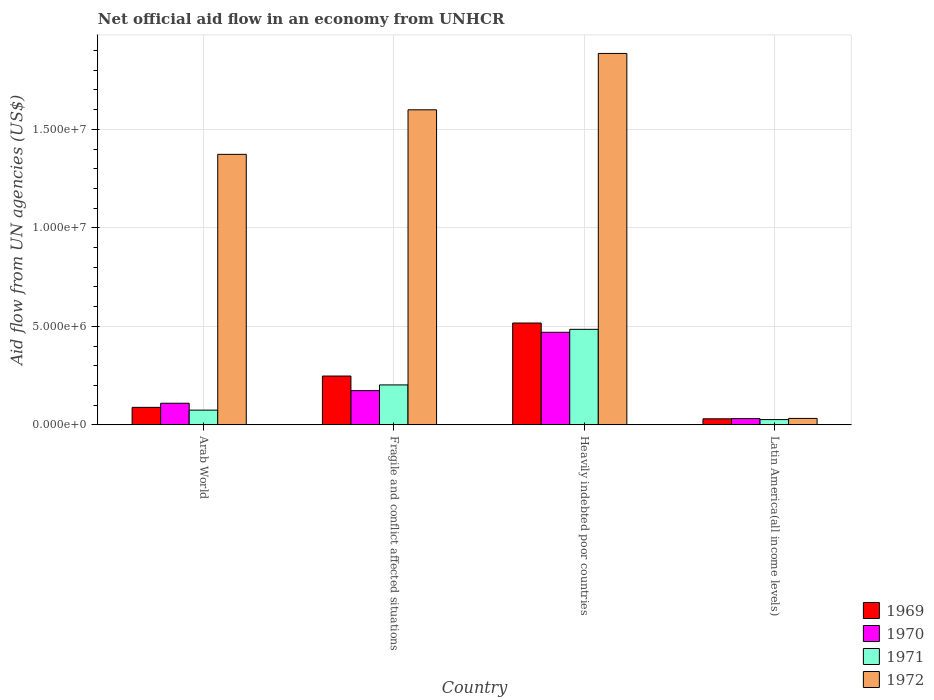How many different coloured bars are there?
Give a very brief answer. 4. How many groups of bars are there?
Give a very brief answer. 4. Are the number of bars per tick equal to the number of legend labels?
Keep it short and to the point. Yes. How many bars are there on the 4th tick from the left?
Provide a short and direct response. 4. How many bars are there on the 1st tick from the right?
Your answer should be compact. 4. What is the label of the 1st group of bars from the left?
Ensure brevity in your answer.  Arab World. What is the net official aid flow in 1969 in Latin America(all income levels)?
Keep it short and to the point. 3.10e+05. Across all countries, what is the maximum net official aid flow in 1969?
Your response must be concise. 5.17e+06. In which country was the net official aid flow in 1971 maximum?
Your answer should be very brief. Heavily indebted poor countries. In which country was the net official aid flow in 1971 minimum?
Offer a terse response. Latin America(all income levels). What is the total net official aid flow in 1969 in the graph?
Keep it short and to the point. 8.85e+06. What is the difference between the net official aid flow in 1971 in Arab World and that in Fragile and conflict affected situations?
Your answer should be very brief. -1.28e+06. What is the difference between the net official aid flow in 1969 in Latin America(all income levels) and the net official aid flow in 1970 in Heavily indebted poor countries?
Your response must be concise. -4.39e+06. What is the average net official aid flow in 1972 per country?
Keep it short and to the point. 1.22e+07. What is the difference between the net official aid flow of/in 1971 and net official aid flow of/in 1970 in Arab World?
Ensure brevity in your answer.  -3.50e+05. In how many countries, is the net official aid flow in 1971 greater than 5000000 US$?
Offer a terse response. 0. What is the ratio of the net official aid flow in 1970 in Fragile and conflict affected situations to that in Heavily indebted poor countries?
Provide a short and direct response. 0.37. Is the net official aid flow in 1970 in Heavily indebted poor countries less than that in Latin America(all income levels)?
Make the answer very short. No. What is the difference between the highest and the second highest net official aid flow in 1972?
Give a very brief answer. 2.86e+06. What is the difference between the highest and the lowest net official aid flow in 1971?
Ensure brevity in your answer.  4.58e+06. Is the sum of the net official aid flow in 1970 in Fragile and conflict affected situations and Latin America(all income levels) greater than the maximum net official aid flow in 1971 across all countries?
Offer a terse response. No. Is it the case that in every country, the sum of the net official aid flow in 1971 and net official aid flow in 1969 is greater than the sum of net official aid flow in 1970 and net official aid flow in 1972?
Keep it short and to the point. No. What does the 4th bar from the right in Latin America(all income levels) represents?
Ensure brevity in your answer.  1969. Are all the bars in the graph horizontal?
Your answer should be compact. No. How many legend labels are there?
Your answer should be compact. 4. How are the legend labels stacked?
Ensure brevity in your answer.  Vertical. What is the title of the graph?
Give a very brief answer. Net official aid flow in an economy from UNHCR. Does "1994" appear as one of the legend labels in the graph?
Provide a succinct answer. No. What is the label or title of the Y-axis?
Ensure brevity in your answer.  Aid flow from UN agencies (US$). What is the Aid flow from UN agencies (US$) of 1969 in Arab World?
Provide a short and direct response. 8.90e+05. What is the Aid flow from UN agencies (US$) of 1970 in Arab World?
Ensure brevity in your answer.  1.10e+06. What is the Aid flow from UN agencies (US$) in 1971 in Arab World?
Give a very brief answer. 7.50e+05. What is the Aid flow from UN agencies (US$) of 1972 in Arab World?
Provide a short and direct response. 1.37e+07. What is the Aid flow from UN agencies (US$) of 1969 in Fragile and conflict affected situations?
Provide a succinct answer. 2.48e+06. What is the Aid flow from UN agencies (US$) of 1970 in Fragile and conflict affected situations?
Provide a short and direct response. 1.74e+06. What is the Aid flow from UN agencies (US$) of 1971 in Fragile and conflict affected situations?
Offer a very short reply. 2.03e+06. What is the Aid flow from UN agencies (US$) of 1972 in Fragile and conflict affected situations?
Provide a succinct answer. 1.60e+07. What is the Aid flow from UN agencies (US$) in 1969 in Heavily indebted poor countries?
Your response must be concise. 5.17e+06. What is the Aid flow from UN agencies (US$) of 1970 in Heavily indebted poor countries?
Provide a succinct answer. 4.70e+06. What is the Aid flow from UN agencies (US$) in 1971 in Heavily indebted poor countries?
Offer a terse response. 4.85e+06. What is the Aid flow from UN agencies (US$) of 1972 in Heavily indebted poor countries?
Your response must be concise. 1.88e+07. What is the Aid flow from UN agencies (US$) of 1971 in Latin America(all income levels)?
Provide a succinct answer. 2.70e+05. Across all countries, what is the maximum Aid flow from UN agencies (US$) in 1969?
Give a very brief answer. 5.17e+06. Across all countries, what is the maximum Aid flow from UN agencies (US$) of 1970?
Keep it short and to the point. 4.70e+06. Across all countries, what is the maximum Aid flow from UN agencies (US$) in 1971?
Ensure brevity in your answer.  4.85e+06. Across all countries, what is the maximum Aid flow from UN agencies (US$) in 1972?
Your answer should be compact. 1.88e+07. Across all countries, what is the minimum Aid flow from UN agencies (US$) of 1969?
Your answer should be very brief. 3.10e+05. Across all countries, what is the minimum Aid flow from UN agencies (US$) in 1972?
Provide a succinct answer. 3.30e+05. What is the total Aid flow from UN agencies (US$) in 1969 in the graph?
Make the answer very short. 8.85e+06. What is the total Aid flow from UN agencies (US$) of 1970 in the graph?
Make the answer very short. 7.86e+06. What is the total Aid flow from UN agencies (US$) in 1971 in the graph?
Your answer should be very brief. 7.90e+06. What is the total Aid flow from UN agencies (US$) of 1972 in the graph?
Offer a terse response. 4.89e+07. What is the difference between the Aid flow from UN agencies (US$) in 1969 in Arab World and that in Fragile and conflict affected situations?
Offer a terse response. -1.59e+06. What is the difference between the Aid flow from UN agencies (US$) in 1970 in Arab World and that in Fragile and conflict affected situations?
Your answer should be compact. -6.40e+05. What is the difference between the Aid flow from UN agencies (US$) of 1971 in Arab World and that in Fragile and conflict affected situations?
Make the answer very short. -1.28e+06. What is the difference between the Aid flow from UN agencies (US$) in 1972 in Arab World and that in Fragile and conflict affected situations?
Keep it short and to the point. -2.26e+06. What is the difference between the Aid flow from UN agencies (US$) in 1969 in Arab World and that in Heavily indebted poor countries?
Provide a succinct answer. -4.28e+06. What is the difference between the Aid flow from UN agencies (US$) in 1970 in Arab World and that in Heavily indebted poor countries?
Your response must be concise. -3.60e+06. What is the difference between the Aid flow from UN agencies (US$) of 1971 in Arab World and that in Heavily indebted poor countries?
Your answer should be compact. -4.10e+06. What is the difference between the Aid flow from UN agencies (US$) in 1972 in Arab World and that in Heavily indebted poor countries?
Make the answer very short. -5.12e+06. What is the difference between the Aid flow from UN agencies (US$) of 1969 in Arab World and that in Latin America(all income levels)?
Provide a short and direct response. 5.80e+05. What is the difference between the Aid flow from UN agencies (US$) of 1970 in Arab World and that in Latin America(all income levels)?
Your answer should be very brief. 7.80e+05. What is the difference between the Aid flow from UN agencies (US$) in 1971 in Arab World and that in Latin America(all income levels)?
Your response must be concise. 4.80e+05. What is the difference between the Aid flow from UN agencies (US$) of 1972 in Arab World and that in Latin America(all income levels)?
Offer a very short reply. 1.34e+07. What is the difference between the Aid flow from UN agencies (US$) in 1969 in Fragile and conflict affected situations and that in Heavily indebted poor countries?
Keep it short and to the point. -2.69e+06. What is the difference between the Aid flow from UN agencies (US$) of 1970 in Fragile and conflict affected situations and that in Heavily indebted poor countries?
Your answer should be very brief. -2.96e+06. What is the difference between the Aid flow from UN agencies (US$) of 1971 in Fragile and conflict affected situations and that in Heavily indebted poor countries?
Your response must be concise. -2.82e+06. What is the difference between the Aid flow from UN agencies (US$) of 1972 in Fragile and conflict affected situations and that in Heavily indebted poor countries?
Give a very brief answer. -2.86e+06. What is the difference between the Aid flow from UN agencies (US$) in 1969 in Fragile and conflict affected situations and that in Latin America(all income levels)?
Offer a very short reply. 2.17e+06. What is the difference between the Aid flow from UN agencies (US$) of 1970 in Fragile and conflict affected situations and that in Latin America(all income levels)?
Your answer should be very brief. 1.42e+06. What is the difference between the Aid flow from UN agencies (US$) of 1971 in Fragile and conflict affected situations and that in Latin America(all income levels)?
Offer a very short reply. 1.76e+06. What is the difference between the Aid flow from UN agencies (US$) in 1972 in Fragile and conflict affected situations and that in Latin America(all income levels)?
Your answer should be compact. 1.57e+07. What is the difference between the Aid flow from UN agencies (US$) of 1969 in Heavily indebted poor countries and that in Latin America(all income levels)?
Your answer should be compact. 4.86e+06. What is the difference between the Aid flow from UN agencies (US$) in 1970 in Heavily indebted poor countries and that in Latin America(all income levels)?
Offer a very short reply. 4.38e+06. What is the difference between the Aid flow from UN agencies (US$) of 1971 in Heavily indebted poor countries and that in Latin America(all income levels)?
Your response must be concise. 4.58e+06. What is the difference between the Aid flow from UN agencies (US$) of 1972 in Heavily indebted poor countries and that in Latin America(all income levels)?
Make the answer very short. 1.85e+07. What is the difference between the Aid flow from UN agencies (US$) of 1969 in Arab World and the Aid flow from UN agencies (US$) of 1970 in Fragile and conflict affected situations?
Provide a short and direct response. -8.50e+05. What is the difference between the Aid flow from UN agencies (US$) in 1969 in Arab World and the Aid flow from UN agencies (US$) in 1971 in Fragile and conflict affected situations?
Provide a succinct answer. -1.14e+06. What is the difference between the Aid flow from UN agencies (US$) of 1969 in Arab World and the Aid flow from UN agencies (US$) of 1972 in Fragile and conflict affected situations?
Your response must be concise. -1.51e+07. What is the difference between the Aid flow from UN agencies (US$) in 1970 in Arab World and the Aid flow from UN agencies (US$) in 1971 in Fragile and conflict affected situations?
Your answer should be compact. -9.30e+05. What is the difference between the Aid flow from UN agencies (US$) in 1970 in Arab World and the Aid flow from UN agencies (US$) in 1972 in Fragile and conflict affected situations?
Your answer should be very brief. -1.49e+07. What is the difference between the Aid flow from UN agencies (US$) in 1971 in Arab World and the Aid flow from UN agencies (US$) in 1972 in Fragile and conflict affected situations?
Offer a very short reply. -1.52e+07. What is the difference between the Aid flow from UN agencies (US$) in 1969 in Arab World and the Aid flow from UN agencies (US$) in 1970 in Heavily indebted poor countries?
Give a very brief answer. -3.81e+06. What is the difference between the Aid flow from UN agencies (US$) in 1969 in Arab World and the Aid flow from UN agencies (US$) in 1971 in Heavily indebted poor countries?
Provide a short and direct response. -3.96e+06. What is the difference between the Aid flow from UN agencies (US$) in 1969 in Arab World and the Aid flow from UN agencies (US$) in 1972 in Heavily indebted poor countries?
Your response must be concise. -1.80e+07. What is the difference between the Aid flow from UN agencies (US$) in 1970 in Arab World and the Aid flow from UN agencies (US$) in 1971 in Heavily indebted poor countries?
Make the answer very short. -3.75e+06. What is the difference between the Aid flow from UN agencies (US$) of 1970 in Arab World and the Aid flow from UN agencies (US$) of 1972 in Heavily indebted poor countries?
Provide a short and direct response. -1.78e+07. What is the difference between the Aid flow from UN agencies (US$) of 1971 in Arab World and the Aid flow from UN agencies (US$) of 1972 in Heavily indebted poor countries?
Offer a very short reply. -1.81e+07. What is the difference between the Aid flow from UN agencies (US$) in 1969 in Arab World and the Aid flow from UN agencies (US$) in 1970 in Latin America(all income levels)?
Your answer should be compact. 5.70e+05. What is the difference between the Aid flow from UN agencies (US$) in 1969 in Arab World and the Aid flow from UN agencies (US$) in 1971 in Latin America(all income levels)?
Make the answer very short. 6.20e+05. What is the difference between the Aid flow from UN agencies (US$) of 1969 in Arab World and the Aid flow from UN agencies (US$) of 1972 in Latin America(all income levels)?
Provide a short and direct response. 5.60e+05. What is the difference between the Aid flow from UN agencies (US$) of 1970 in Arab World and the Aid flow from UN agencies (US$) of 1971 in Latin America(all income levels)?
Offer a very short reply. 8.30e+05. What is the difference between the Aid flow from UN agencies (US$) in 1970 in Arab World and the Aid flow from UN agencies (US$) in 1972 in Latin America(all income levels)?
Your answer should be compact. 7.70e+05. What is the difference between the Aid flow from UN agencies (US$) in 1971 in Arab World and the Aid flow from UN agencies (US$) in 1972 in Latin America(all income levels)?
Ensure brevity in your answer.  4.20e+05. What is the difference between the Aid flow from UN agencies (US$) of 1969 in Fragile and conflict affected situations and the Aid flow from UN agencies (US$) of 1970 in Heavily indebted poor countries?
Ensure brevity in your answer.  -2.22e+06. What is the difference between the Aid flow from UN agencies (US$) in 1969 in Fragile and conflict affected situations and the Aid flow from UN agencies (US$) in 1971 in Heavily indebted poor countries?
Provide a short and direct response. -2.37e+06. What is the difference between the Aid flow from UN agencies (US$) in 1969 in Fragile and conflict affected situations and the Aid flow from UN agencies (US$) in 1972 in Heavily indebted poor countries?
Keep it short and to the point. -1.64e+07. What is the difference between the Aid flow from UN agencies (US$) in 1970 in Fragile and conflict affected situations and the Aid flow from UN agencies (US$) in 1971 in Heavily indebted poor countries?
Offer a terse response. -3.11e+06. What is the difference between the Aid flow from UN agencies (US$) of 1970 in Fragile and conflict affected situations and the Aid flow from UN agencies (US$) of 1972 in Heavily indebted poor countries?
Keep it short and to the point. -1.71e+07. What is the difference between the Aid flow from UN agencies (US$) in 1971 in Fragile and conflict affected situations and the Aid flow from UN agencies (US$) in 1972 in Heavily indebted poor countries?
Your response must be concise. -1.68e+07. What is the difference between the Aid flow from UN agencies (US$) in 1969 in Fragile and conflict affected situations and the Aid flow from UN agencies (US$) in 1970 in Latin America(all income levels)?
Offer a very short reply. 2.16e+06. What is the difference between the Aid flow from UN agencies (US$) of 1969 in Fragile and conflict affected situations and the Aid flow from UN agencies (US$) of 1971 in Latin America(all income levels)?
Provide a succinct answer. 2.21e+06. What is the difference between the Aid flow from UN agencies (US$) in 1969 in Fragile and conflict affected situations and the Aid flow from UN agencies (US$) in 1972 in Latin America(all income levels)?
Your answer should be compact. 2.15e+06. What is the difference between the Aid flow from UN agencies (US$) of 1970 in Fragile and conflict affected situations and the Aid flow from UN agencies (US$) of 1971 in Latin America(all income levels)?
Ensure brevity in your answer.  1.47e+06. What is the difference between the Aid flow from UN agencies (US$) in 1970 in Fragile and conflict affected situations and the Aid flow from UN agencies (US$) in 1972 in Latin America(all income levels)?
Provide a short and direct response. 1.41e+06. What is the difference between the Aid flow from UN agencies (US$) in 1971 in Fragile and conflict affected situations and the Aid flow from UN agencies (US$) in 1972 in Latin America(all income levels)?
Offer a very short reply. 1.70e+06. What is the difference between the Aid flow from UN agencies (US$) in 1969 in Heavily indebted poor countries and the Aid flow from UN agencies (US$) in 1970 in Latin America(all income levels)?
Keep it short and to the point. 4.85e+06. What is the difference between the Aid flow from UN agencies (US$) in 1969 in Heavily indebted poor countries and the Aid flow from UN agencies (US$) in 1971 in Latin America(all income levels)?
Ensure brevity in your answer.  4.90e+06. What is the difference between the Aid flow from UN agencies (US$) in 1969 in Heavily indebted poor countries and the Aid flow from UN agencies (US$) in 1972 in Latin America(all income levels)?
Ensure brevity in your answer.  4.84e+06. What is the difference between the Aid flow from UN agencies (US$) in 1970 in Heavily indebted poor countries and the Aid flow from UN agencies (US$) in 1971 in Latin America(all income levels)?
Your answer should be very brief. 4.43e+06. What is the difference between the Aid flow from UN agencies (US$) in 1970 in Heavily indebted poor countries and the Aid flow from UN agencies (US$) in 1972 in Latin America(all income levels)?
Make the answer very short. 4.37e+06. What is the difference between the Aid flow from UN agencies (US$) in 1971 in Heavily indebted poor countries and the Aid flow from UN agencies (US$) in 1972 in Latin America(all income levels)?
Provide a short and direct response. 4.52e+06. What is the average Aid flow from UN agencies (US$) of 1969 per country?
Your response must be concise. 2.21e+06. What is the average Aid flow from UN agencies (US$) of 1970 per country?
Provide a short and direct response. 1.96e+06. What is the average Aid flow from UN agencies (US$) in 1971 per country?
Ensure brevity in your answer.  1.98e+06. What is the average Aid flow from UN agencies (US$) of 1972 per country?
Offer a very short reply. 1.22e+07. What is the difference between the Aid flow from UN agencies (US$) in 1969 and Aid flow from UN agencies (US$) in 1970 in Arab World?
Offer a terse response. -2.10e+05. What is the difference between the Aid flow from UN agencies (US$) of 1969 and Aid flow from UN agencies (US$) of 1971 in Arab World?
Ensure brevity in your answer.  1.40e+05. What is the difference between the Aid flow from UN agencies (US$) of 1969 and Aid flow from UN agencies (US$) of 1972 in Arab World?
Give a very brief answer. -1.28e+07. What is the difference between the Aid flow from UN agencies (US$) of 1970 and Aid flow from UN agencies (US$) of 1972 in Arab World?
Your response must be concise. -1.26e+07. What is the difference between the Aid flow from UN agencies (US$) of 1971 and Aid flow from UN agencies (US$) of 1972 in Arab World?
Offer a very short reply. -1.30e+07. What is the difference between the Aid flow from UN agencies (US$) in 1969 and Aid flow from UN agencies (US$) in 1970 in Fragile and conflict affected situations?
Your response must be concise. 7.40e+05. What is the difference between the Aid flow from UN agencies (US$) of 1969 and Aid flow from UN agencies (US$) of 1972 in Fragile and conflict affected situations?
Your response must be concise. -1.35e+07. What is the difference between the Aid flow from UN agencies (US$) in 1970 and Aid flow from UN agencies (US$) in 1971 in Fragile and conflict affected situations?
Ensure brevity in your answer.  -2.90e+05. What is the difference between the Aid flow from UN agencies (US$) in 1970 and Aid flow from UN agencies (US$) in 1972 in Fragile and conflict affected situations?
Offer a terse response. -1.42e+07. What is the difference between the Aid flow from UN agencies (US$) in 1971 and Aid flow from UN agencies (US$) in 1972 in Fragile and conflict affected situations?
Give a very brief answer. -1.40e+07. What is the difference between the Aid flow from UN agencies (US$) in 1969 and Aid flow from UN agencies (US$) in 1972 in Heavily indebted poor countries?
Your answer should be compact. -1.37e+07. What is the difference between the Aid flow from UN agencies (US$) in 1970 and Aid flow from UN agencies (US$) in 1971 in Heavily indebted poor countries?
Provide a succinct answer. -1.50e+05. What is the difference between the Aid flow from UN agencies (US$) of 1970 and Aid flow from UN agencies (US$) of 1972 in Heavily indebted poor countries?
Give a very brief answer. -1.42e+07. What is the difference between the Aid flow from UN agencies (US$) in 1971 and Aid flow from UN agencies (US$) in 1972 in Heavily indebted poor countries?
Ensure brevity in your answer.  -1.40e+07. What is the difference between the Aid flow from UN agencies (US$) of 1969 and Aid flow from UN agencies (US$) of 1971 in Latin America(all income levels)?
Provide a short and direct response. 4.00e+04. What is the difference between the Aid flow from UN agencies (US$) in 1969 and Aid flow from UN agencies (US$) in 1972 in Latin America(all income levels)?
Ensure brevity in your answer.  -2.00e+04. What is the difference between the Aid flow from UN agencies (US$) in 1970 and Aid flow from UN agencies (US$) in 1972 in Latin America(all income levels)?
Make the answer very short. -10000. What is the ratio of the Aid flow from UN agencies (US$) of 1969 in Arab World to that in Fragile and conflict affected situations?
Give a very brief answer. 0.36. What is the ratio of the Aid flow from UN agencies (US$) in 1970 in Arab World to that in Fragile and conflict affected situations?
Offer a terse response. 0.63. What is the ratio of the Aid flow from UN agencies (US$) of 1971 in Arab World to that in Fragile and conflict affected situations?
Offer a terse response. 0.37. What is the ratio of the Aid flow from UN agencies (US$) in 1972 in Arab World to that in Fragile and conflict affected situations?
Give a very brief answer. 0.86. What is the ratio of the Aid flow from UN agencies (US$) in 1969 in Arab World to that in Heavily indebted poor countries?
Offer a very short reply. 0.17. What is the ratio of the Aid flow from UN agencies (US$) in 1970 in Arab World to that in Heavily indebted poor countries?
Give a very brief answer. 0.23. What is the ratio of the Aid flow from UN agencies (US$) of 1971 in Arab World to that in Heavily indebted poor countries?
Ensure brevity in your answer.  0.15. What is the ratio of the Aid flow from UN agencies (US$) in 1972 in Arab World to that in Heavily indebted poor countries?
Your answer should be compact. 0.73. What is the ratio of the Aid flow from UN agencies (US$) of 1969 in Arab World to that in Latin America(all income levels)?
Make the answer very short. 2.87. What is the ratio of the Aid flow from UN agencies (US$) in 1970 in Arab World to that in Latin America(all income levels)?
Give a very brief answer. 3.44. What is the ratio of the Aid flow from UN agencies (US$) in 1971 in Arab World to that in Latin America(all income levels)?
Your answer should be very brief. 2.78. What is the ratio of the Aid flow from UN agencies (US$) in 1972 in Arab World to that in Latin America(all income levels)?
Your answer should be compact. 41.61. What is the ratio of the Aid flow from UN agencies (US$) in 1969 in Fragile and conflict affected situations to that in Heavily indebted poor countries?
Provide a succinct answer. 0.48. What is the ratio of the Aid flow from UN agencies (US$) of 1970 in Fragile and conflict affected situations to that in Heavily indebted poor countries?
Offer a very short reply. 0.37. What is the ratio of the Aid flow from UN agencies (US$) of 1971 in Fragile and conflict affected situations to that in Heavily indebted poor countries?
Ensure brevity in your answer.  0.42. What is the ratio of the Aid flow from UN agencies (US$) of 1972 in Fragile and conflict affected situations to that in Heavily indebted poor countries?
Your answer should be very brief. 0.85. What is the ratio of the Aid flow from UN agencies (US$) of 1969 in Fragile and conflict affected situations to that in Latin America(all income levels)?
Offer a terse response. 8. What is the ratio of the Aid flow from UN agencies (US$) in 1970 in Fragile and conflict affected situations to that in Latin America(all income levels)?
Your answer should be compact. 5.44. What is the ratio of the Aid flow from UN agencies (US$) in 1971 in Fragile and conflict affected situations to that in Latin America(all income levels)?
Your response must be concise. 7.52. What is the ratio of the Aid flow from UN agencies (US$) of 1972 in Fragile and conflict affected situations to that in Latin America(all income levels)?
Provide a short and direct response. 48.45. What is the ratio of the Aid flow from UN agencies (US$) of 1969 in Heavily indebted poor countries to that in Latin America(all income levels)?
Keep it short and to the point. 16.68. What is the ratio of the Aid flow from UN agencies (US$) of 1970 in Heavily indebted poor countries to that in Latin America(all income levels)?
Your answer should be very brief. 14.69. What is the ratio of the Aid flow from UN agencies (US$) of 1971 in Heavily indebted poor countries to that in Latin America(all income levels)?
Offer a very short reply. 17.96. What is the ratio of the Aid flow from UN agencies (US$) of 1972 in Heavily indebted poor countries to that in Latin America(all income levels)?
Your answer should be compact. 57.12. What is the difference between the highest and the second highest Aid flow from UN agencies (US$) in 1969?
Your answer should be very brief. 2.69e+06. What is the difference between the highest and the second highest Aid flow from UN agencies (US$) in 1970?
Your answer should be very brief. 2.96e+06. What is the difference between the highest and the second highest Aid flow from UN agencies (US$) of 1971?
Provide a succinct answer. 2.82e+06. What is the difference between the highest and the second highest Aid flow from UN agencies (US$) of 1972?
Your answer should be very brief. 2.86e+06. What is the difference between the highest and the lowest Aid flow from UN agencies (US$) of 1969?
Ensure brevity in your answer.  4.86e+06. What is the difference between the highest and the lowest Aid flow from UN agencies (US$) in 1970?
Your answer should be very brief. 4.38e+06. What is the difference between the highest and the lowest Aid flow from UN agencies (US$) in 1971?
Keep it short and to the point. 4.58e+06. What is the difference between the highest and the lowest Aid flow from UN agencies (US$) of 1972?
Make the answer very short. 1.85e+07. 